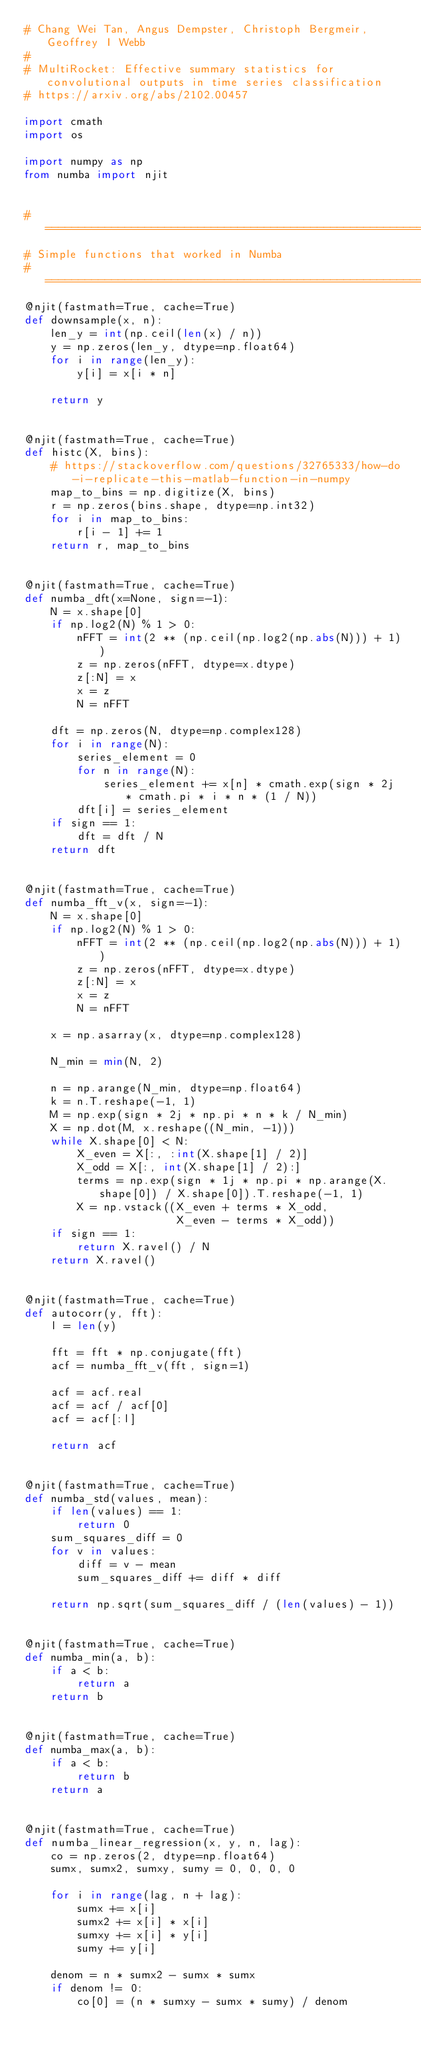<code> <loc_0><loc_0><loc_500><loc_500><_Python_># Chang Wei Tan, Angus Dempster, Christoph Bergmeir, Geoffrey I Webb
#
# MultiRocket: Effective summary statistics for convolutional outputs in time series classification
# https://arxiv.org/abs/2102.00457

import cmath
import os

import numpy as np
from numba import njit


# =======================================================================================================
# Simple functions that worked in Numba
# =======================================================================================================
@njit(fastmath=True, cache=True)
def downsample(x, n):
    len_y = int(np.ceil(len(x) / n))
    y = np.zeros(len_y, dtype=np.float64)
    for i in range(len_y):
        y[i] = x[i * n]

    return y


@njit(fastmath=True, cache=True)
def histc(X, bins):
    # https://stackoverflow.com/questions/32765333/how-do-i-replicate-this-matlab-function-in-numpy
    map_to_bins = np.digitize(X, bins)
    r = np.zeros(bins.shape, dtype=np.int32)
    for i in map_to_bins:
        r[i - 1] += 1
    return r, map_to_bins


@njit(fastmath=True, cache=True)
def numba_dft(x=None, sign=-1):
    N = x.shape[0]
    if np.log2(N) % 1 > 0:
        nFFT = int(2 ** (np.ceil(np.log2(np.abs(N))) + 1))
        z = np.zeros(nFFT, dtype=x.dtype)
        z[:N] = x
        x = z
        N = nFFT

    dft = np.zeros(N, dtype=np.complex128)
    for i in range(N):
        series_element = 0
        for n in range(N):
            series_element += x[n] * cmath.exp(sign * 2j * cmath.pi * i * n * (1 / N))
        dft[i] = series_element
    if sign == 1:
        dft = dft / N
    return dft


@njit(fastmath=True, cache=True)
def numba_fft_v(x, sign=-1):
    N = x.shape[0]
    if np.log2(N) % 1 > 0:
        nFFT = int(2 ** (np.ceil(np.log2(np.abs(N))) + 1))
        z = np.zeros(nFFT, dtype=x.dtype)
        z[:N] = x
        x = z
        N = nFFT

    x = np.asarray(x, dtype=np.complex128)

    N_min = min(N, 2)

    n = np.arange(N_min, dtype=np.float64)
    k = n.T.reshape(-1, 1)
    M = np.exp(sign * 2j * np.pi * n * k / N_min)
    X = np.dot(M, x.reshape((N_min, -1)))
    while X.shape[0] < N:
        X_even = X[:, :int(X.shape[1] / 2)]
        X_odd = X[:, int(X.shape[1] / 2):]
        terms = np.exp(sign * 1j * np.pi * np.arange(X.shape[0]) / X.shape[0]).T.reshape(-1, 1)
        X = np.vstack((X_even + terms * X_odd,
                       X_even - terms * X_odd))
    if sign == 1:
        return X.ravel() / N
    return X.ravel()


@njit(fastmath=True, cache=True)
def autocorr(y, fft):
    l = len(y)

    fft = fft * np.conjugate(fft)
    acf = numba_fft_v(fft, sign=1)

    acf = acf.real
    acf = acf / acf[0]
    acf = acf[:l]

    return acf


@njit(fastmath=True, cache=True)
def numba_std(values, mean):
    if len(values) == 1:
        return 0
    sum_squares_diff = 0
    for v in values:
        diff = v - mean
        sum_squares_diff += diff * diff

    return np.sqrt(sum_squares_diff / (len(values) - 1))


@njit(fastmath=True, cache=True)
def numba_min(a, b):
    if a < b:
        return a
    return b


@njit(fastmath=True, cache=True)
def numba_max(a, b):
    if a < b:
        return b
    return a


@njit(fastmath=True, cache=True)
def numba_linear_regression(x, y, n, lag):
    co = np.zeros(2, dtype=np.float64)
    sumx, sumx2, sumxy, sumy = 0, 0, 0, 0

    for i in range(lag, n + lag):
        sumx += x[i]
        sumx2 += x[i] * x[i]
        sumxy += x[i] * y[i]
        sumy += y[i]

    denom = n * sumx2 - sumx * sumx
    if denom != 0:
        co[0] = (n * sumxy - sumx * sumy) / denom</code> 